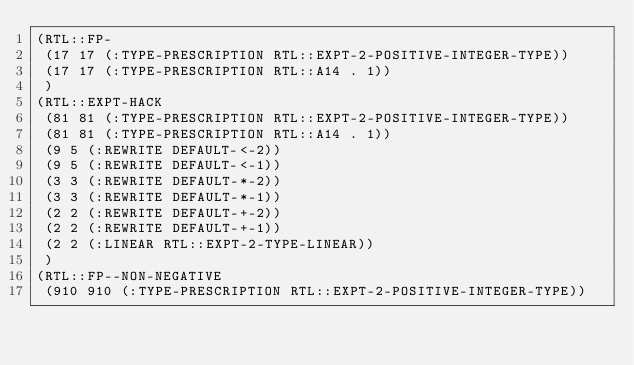Convert code to text. <code><loc_0><loc_0><loc_500><loc_500><_Lisp_>(RTL::FP-
 (17 17 (:TYPE-PRESCRIPTION RTL::EXPT-2-POSITIVE-INTEGER-TYPE))
 (17 17 (:TYPE-PRESCRIPTION RTL::A14 . 1))
 )
(RTL::EXPT-HACK
 (81 81 (:TYPE-PRESCRIPTION RTL::EXPT-2-POSITIVE-INTEGER-TYPE))
 (81 81 (:TYPE-PRESCRIPTION RTL::A14 . 1))
 (9 5 (:REWRITE DEFAULT-<-2))
 (9 5 (:REWRITE DEFAULT-<-1))
 (3 3 (:REWRITE DEFAULT-*-2))
 (3 3 (:REWRITE DEFAULT-*-1))
 (2 2 (:REWRITE DEFAULT-+-2))
 (2 2 (:REWRITE DEFAULT-+-1))
 (2 2 (:LINEAR RTL::EXPT-2-TYPE-LINEAR))
 )
(RTL::FP--NON-NEGATIVE
 (910 910 (:TYPE-PRESCRIPTION RTL::EXPT-2-POSITIVE-INTEGER-TYPE))</code> 